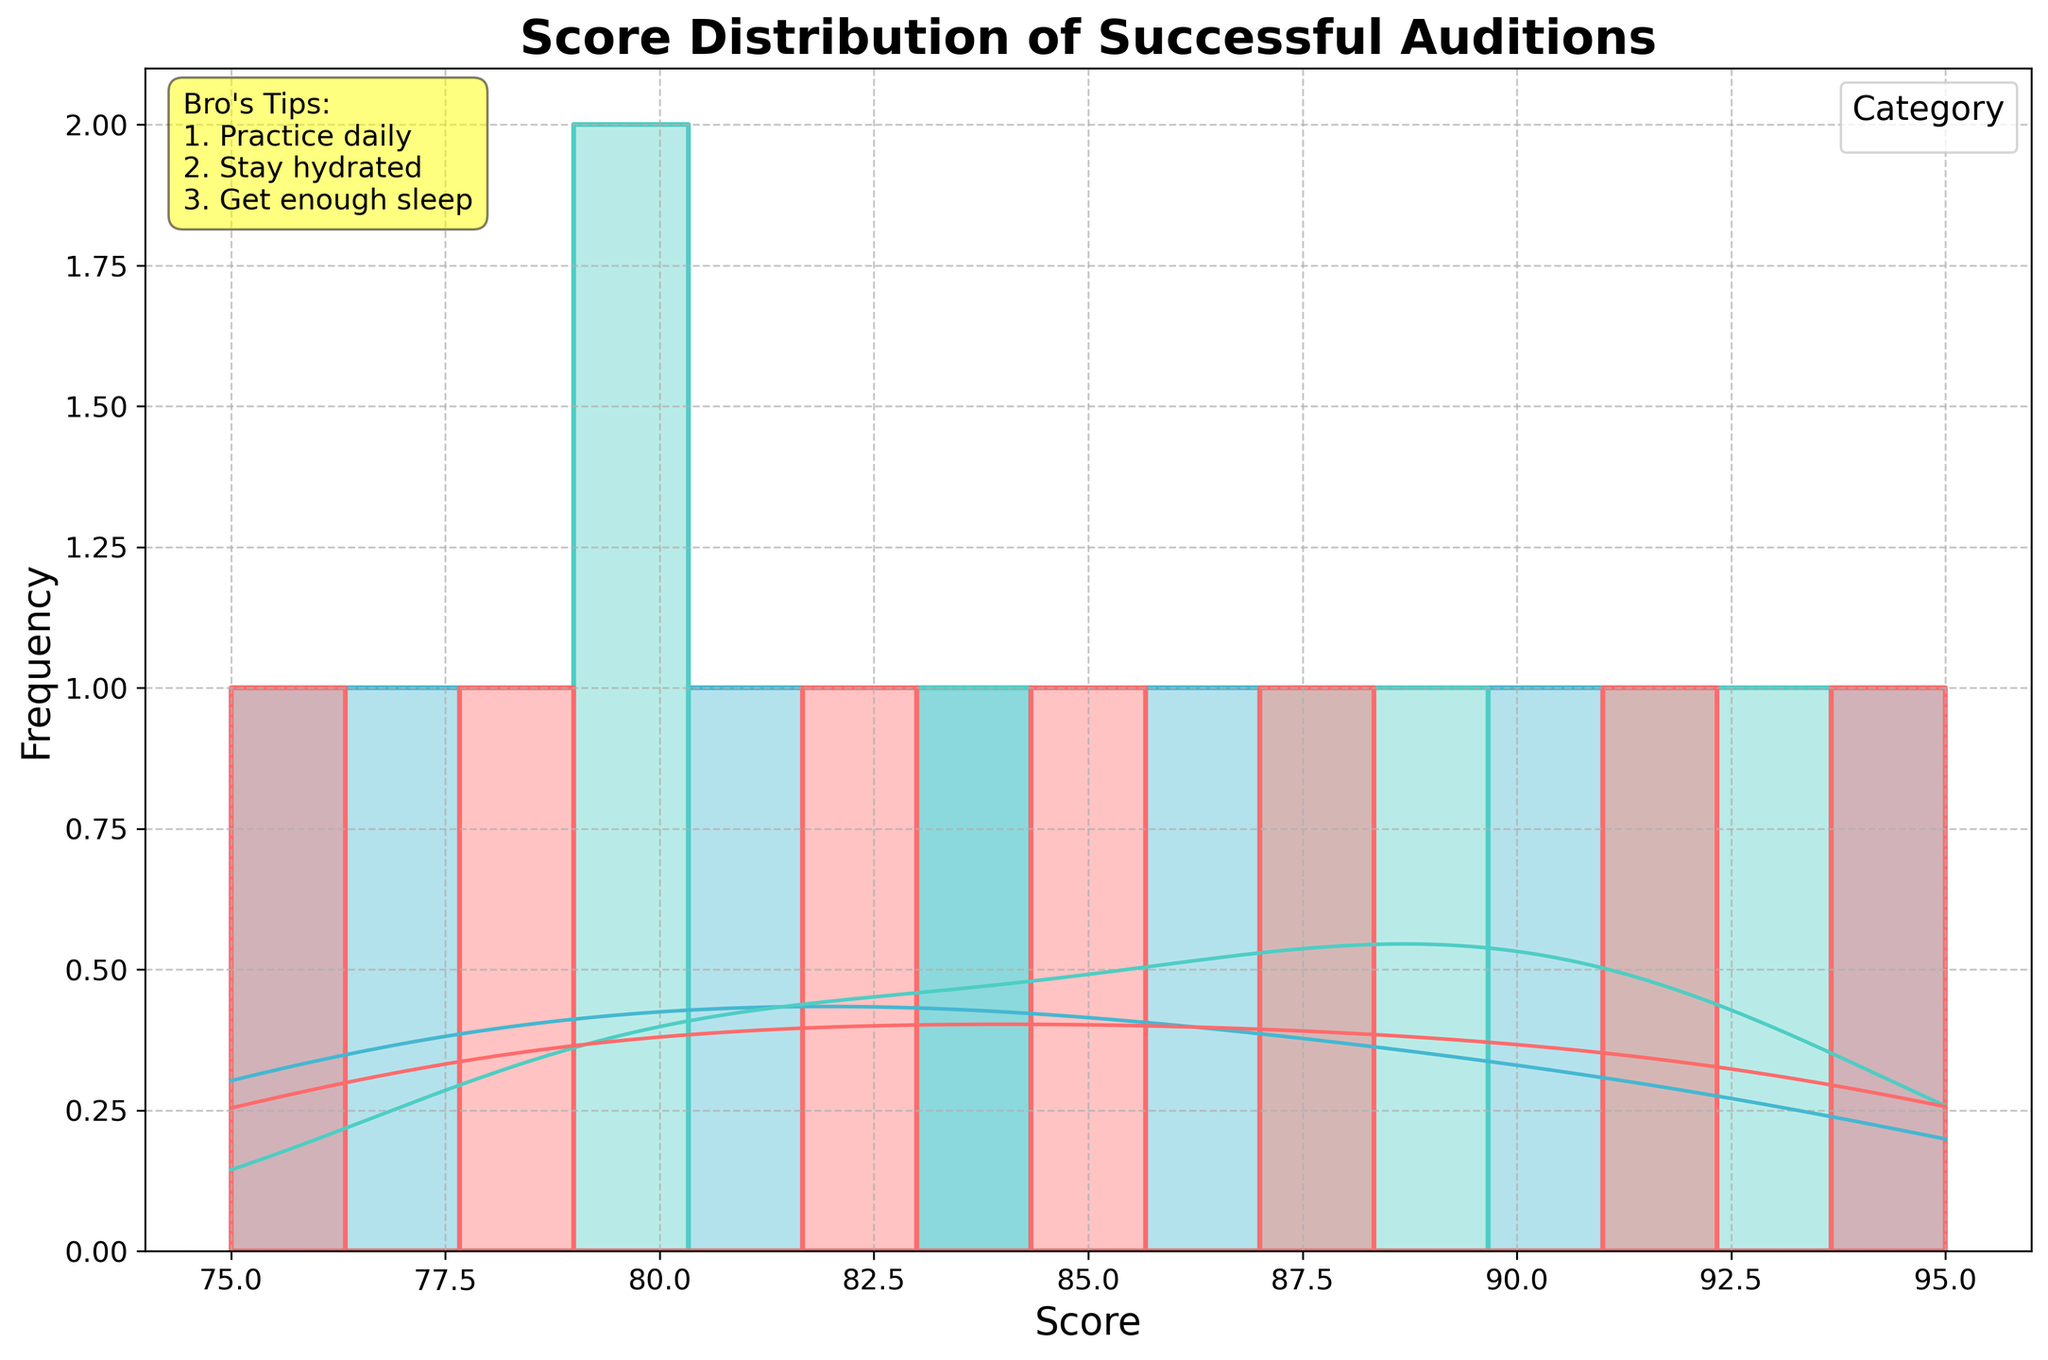what is the title of the plot? The title is located at the top center of the plot and displays the main theme of the visualization.
Answer: Score Distribution of Successful Auditions what are the categories shown in the plot? The categories are differentiated by colors and indicated in the legend on the right side of the plot.
Answer: Singing, Dancing, Acting Which category seems to have the lowest peak in the density curve? Look at the KDE (density) curves and compare their peak heights. The curve with the lowest peak corresponds to the category with the lowest density at its highest point.
Answer: Acting How many performance categories are shown in the histogram? The histogram's hue (color) separation and the legend tell us how many categories are included.
Answer: 3 Which category shows the widest score distribution in the histogram? Look at each histogram’s spread - from the lowest to the highest score - and the density curves. The category with the widest spread has the most scores over a larger range.
Answer: Dancing What's the average highest KDE value for the Singing category? Assess the peak of the KDE curve for the Singing category and approximate its average value.
Answer: Around 0.04 Between Singing and Dancing, which category has higher scores? Compare the KDE peaks and histograms for both categories to identify which has scores predominantly on the higher end.
Answer: Dancing What range of scores do most acting performances fall into? Examine the KDE and histogram for the Acting category, focusing on where the highest frequency or density is observed.
Answer: Between 75 and 90 Can you determine which category has the most consistent scores? Look at the sharpest and most centralized KDE curve; the most consistent category will have scores that cluster closely together.
Answer: Singing How do the peak densities of the categories compare? Compare the KDE peak heights of each category to see which has the highest density at its peak.
Answer: Dancing > Singing > Acting 